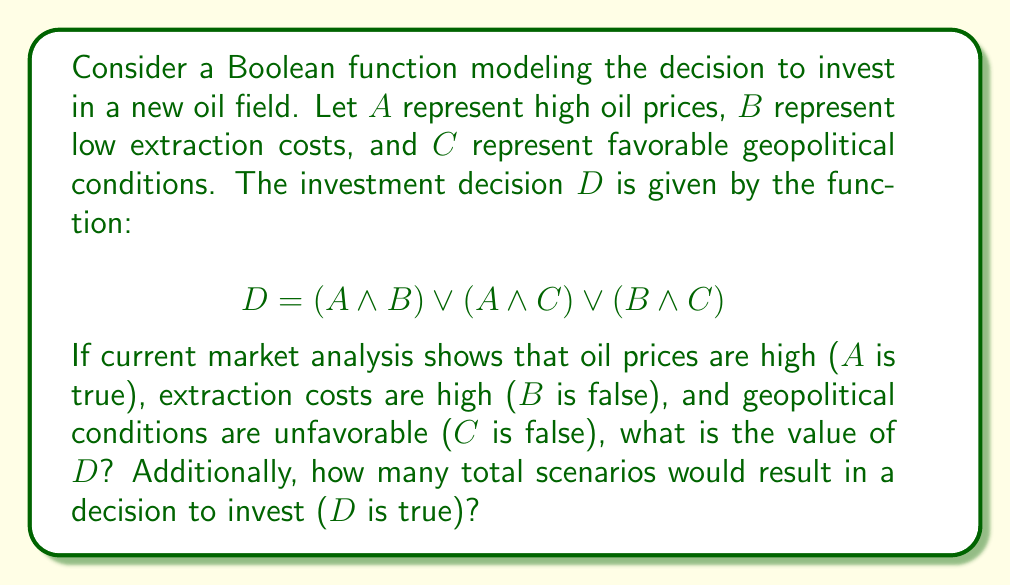Could you help me with this problem? Let's approach this step-by-step:

1) First, let's evaluate $D$ given the current conditions:
   $A = 1$ (true), $B = 0$ (false), $C = 0$ (false)

2) Substituting these values into the function:
   $D = (1 \land 0) \lor (1 \land 0) \lor (0 \land 0)$

3) Evaluating each term:
   $(1 \land 0) = 0$
   $(1 \land 0) = 0$
   $(0 \land 0) = 0$

4) Therefore:
   $D = 0 \lor 0 \lor 0 = 0$

5) To determine how many scenarios result in $D$ being true, we need to consider all possible combinations of $A$, $B$, and $C$. There are $2^3 = 8$ total combinations.

6) Let's evaluate $D$ for each combination:

   $A$ $B$ $C$ | $D$
   0   0   0   | 0
   0   0   1   | 0
   0   1   0   | 0
   0   1   1   | 1
   1   0   0   | 0
   1   0   1   | 1
   1   1   0   | 1
   1   1   1   | 1

7) Counting the number of 1's in the $D$ column, we see that there are 4 scenarios where $D$ is true.
Answer: $D = 0$; 4 scenarios 